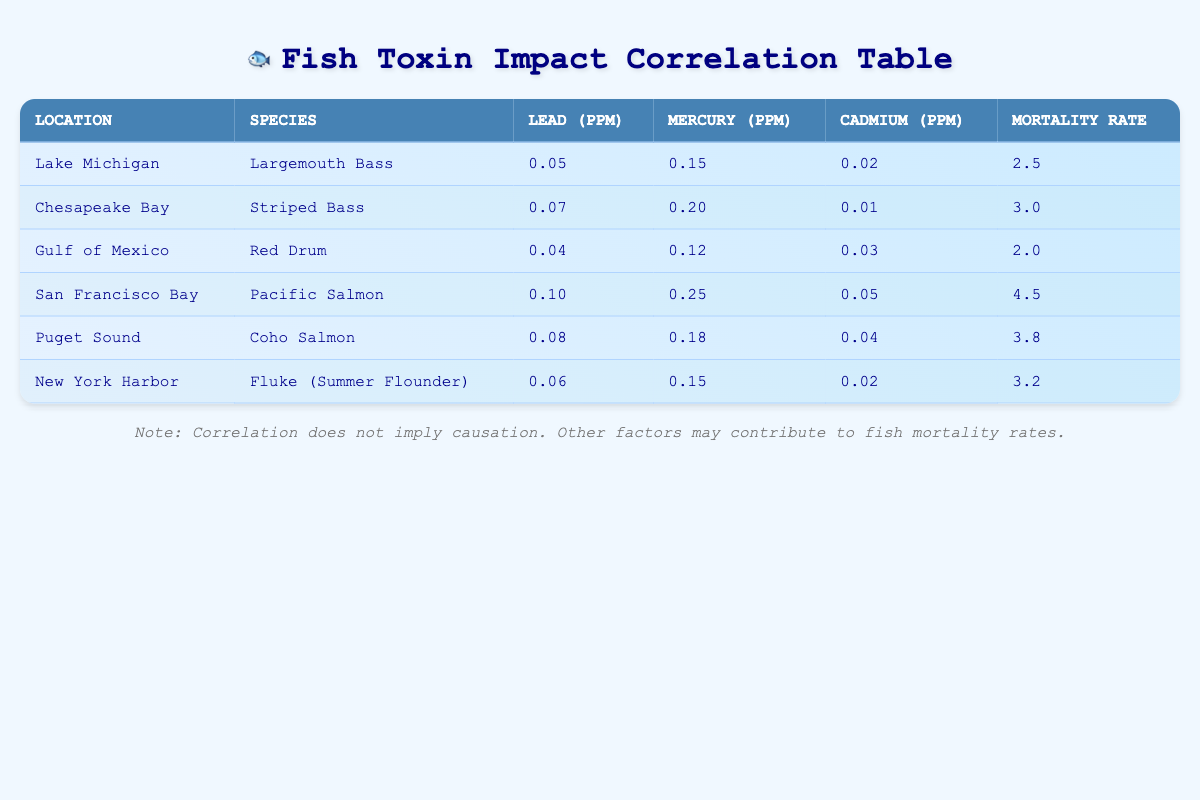What is the lead concentration in San Francisco Bay? Referring to the table, in the row corresponding to San Francisco Bay, the lead concentration is listed as 0.10 ppm.
Answer: 0.10 ppm Which species has the highest fish mortality rate? Looking at the "Fish mortality rate" column, the highest value is 4.5, which belongs to the Pacific Salmon in San Francisco Bay.
Answer: Pacific Salmon What is the average mercury concentration across all locations? To find the average, sum the mercury concentrations: (0.15 + 0.20 + 0.12 + 0.25 + 0.18 + 0.15) = 1.05 ppm. There are 6 locations, so the average is 1.05/6 = 0.175 ppm.
Answer: 0.175 ppm Is the cadmium concentration in the Gulf of Mexico higher than in the Chesapeake Bay? The cadmium concentration in the Gulf of Mexico is 0.03 ppm, while in Chesapeake Bay it is 0.01 ppm. Since 0.03 > 0.01, the statement is true.
Answer: Yes Which location has a lead concentration lower than 0.06 ppm? By reviewing the lead concentrations, only the Gulf of Mexico has a lead concentration of 0.04 ppm, which is lower than 0.06 ppm.
Answer: Gulf of Mexico What is the difference in fish mortality rate between Largemouth Bass and Coho Salmon? The mortality rate for Largemouth Bass is 2.5 and for Coho Salmon is 3.8. The difference is 3.8 - 2.5 = 1.3.
Answer: 1.3 What percentage of species have fish mortality rates above 3.0? The species with mortality rates above 3.0 are the Pacific Salmon (4.5), Coho Salmon (3.8), and Fluke (Summer Flounder) (3.2). There are 3 such species out of a total of 6, so the percentage is (3/6) * 100 = 50%.
Answer: 50% Is there a species in the table with a mercury concentration of 0.25 ppm? Checking the mercury concentrations, the Pacific Salmon in San Francisco Bay has a mercury level of 0.25 ppm. Thus, the answer is affirmative.
Answer: Yes What is the total cadmium concentration across all locations? Summing the cadmium concentrations yields (0.02 + 0.01 + 0.03 + 0.05 + 0.04 + 0.02) = 0.17 ppm total for all locations.
Answer: 0.17 ppm 